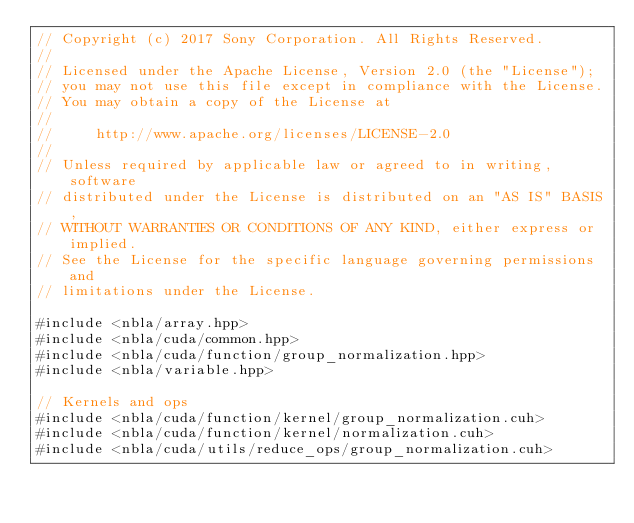<code> <loc_0><loc_0><loc_500><loc_500><_Cuda_>// Copyright (c) 2017 Sony Corporation. All Rights Reserved.
//
// Licensed under the Apache License, Version 2.0 (the "License");
// you may not use this file except in compliance with the License.
// You may obtain a copy of the License at
//
//     http://www.apache.org/licenses/LICENSE-2.0
//
// Unless required by applicable law or agreed to in writing, software
// distributed under the License is distributed on an "AS IS" BASIS,
// WITHOUT WARRANTIES OR CONDITIONS OF ANY KIND, either express or implied.
// See the License for the specific language governing permissions and
// limitations under the License.

#include <nbla/array.hpp>
#include <nbla/cuda/common.hpp>
#include <nbla/cuda/function/group_normalization.hpp>
#include <nbla/variable.hpp>

// Kernels and ops
#include <nbla/cuda/function/kernel/group_normalization.cuh>
#include <nbla/cuda/function/kernel/normalization.cuh>
#include <nbla/cuda/utils/reduce_ops/group_normalization.cuh></code> 